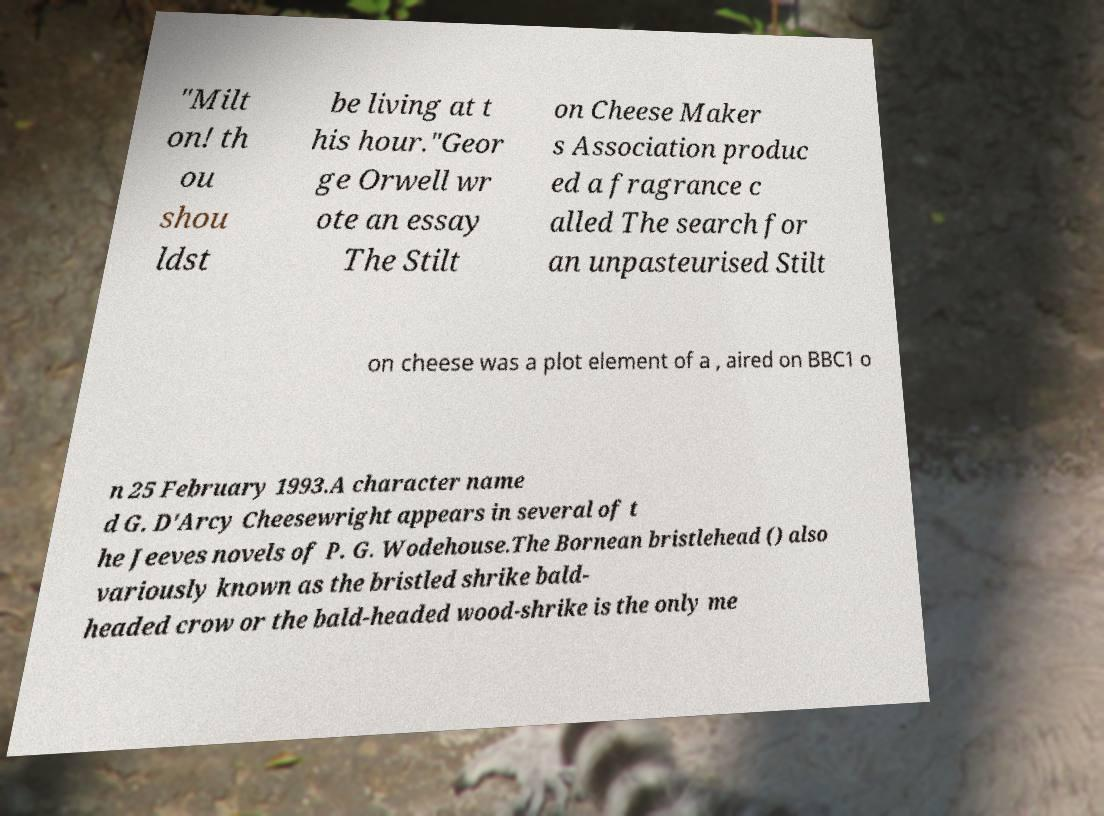I need the written content from this picture converted into text. Can you do that? "Milt on! th ou shou ldst be living at t his hour."Geor ge Orwell wr ote an essay The Stilt on Cheese Maker s Association produc ed a fragrance c alled The search for an unpasteurised Stilt on cheese was a plot element of a , aired on BBC1 o n 25 February 1993.A character name d G. D'Arcy Cheesewright appears in several of t he Jeeves novels of P. G. Wodehouse.The Bornean bristlehead () also variously known as the bristled shrike bald- headed crow or the bald-headed wood-shrike is the only me 